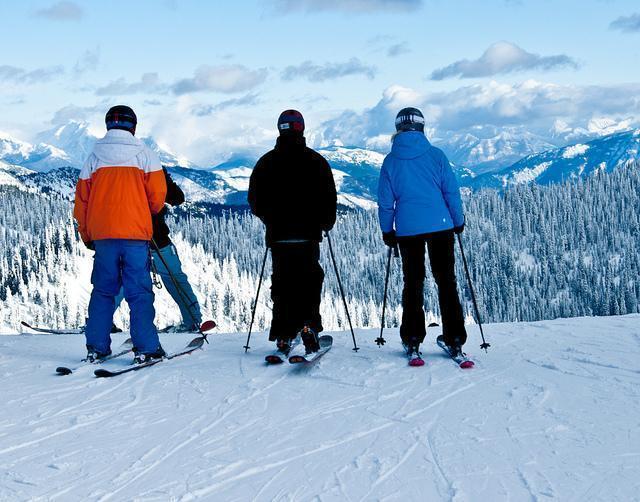What are the people surrounded by?
Pick the right solution, then justify: 'Answer: answer
Rationale: rationale.'
Options: Coyotes, snow, eels, potted shrubbery. Answer: snow.
Rationale: They are on a mountain for skiiing where snow is. 